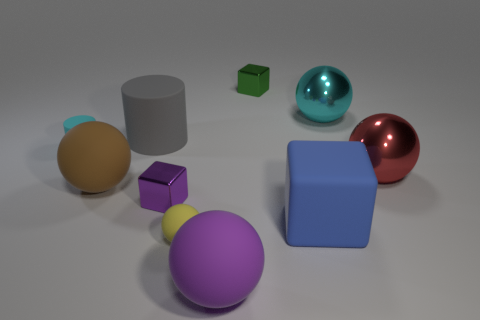Is the material of the purple thing in front of the purple shiny cube the same as the gray object?
Offer a very short reply. Yes. Does the red object have the same shape as the small green metal thing?
Your answer should be very brief. No. What number of things are tiny blocks to the left of the green object or brown balls?
Ensure brevity in your answer.  2. What size is the cyan cylinder that is made of the same material as the big brown thing?
Ensure brevity in your answer.  Small. How many things are the same color as the tiny matte cylinder?
Your answer should be very brief. 1. How many big objects are either blue cubes or cyan spheres?
Offer a terse response. 2. Is there another gray sphere made of the same material as the tiny ball?
Ensure brevity in your answer.  No. There is a block that is behind the red metallic sphere; what is it made of?
Your response must be concise. Metal. Do the small matte thing that is behind the blue block and the big shiny sphere behind the large gray thing have the same color?
Your answer should be very brief. Yes. The cylinder that is the same size as the red shiny thing is what color?
Offer a very short reply. Gray. 